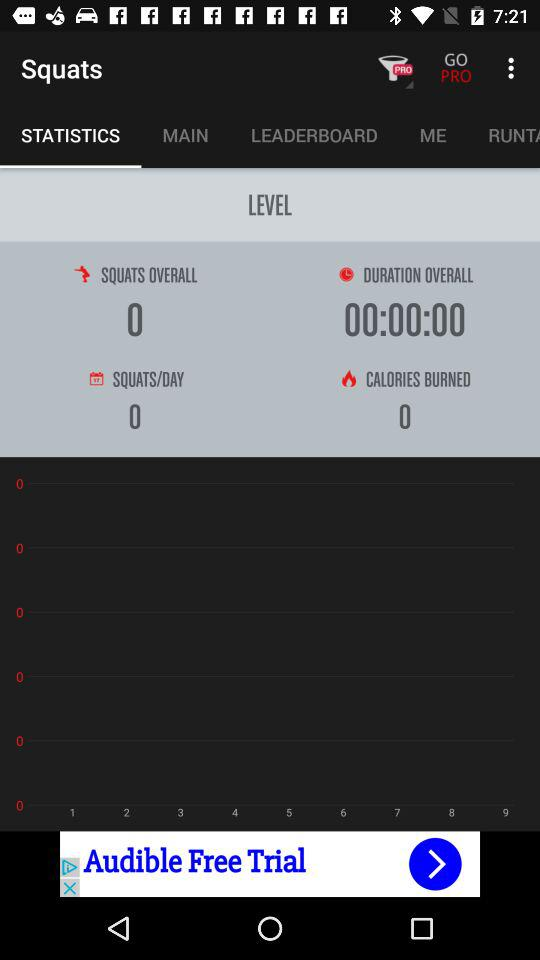What is the application name? The application name is "Squats". 